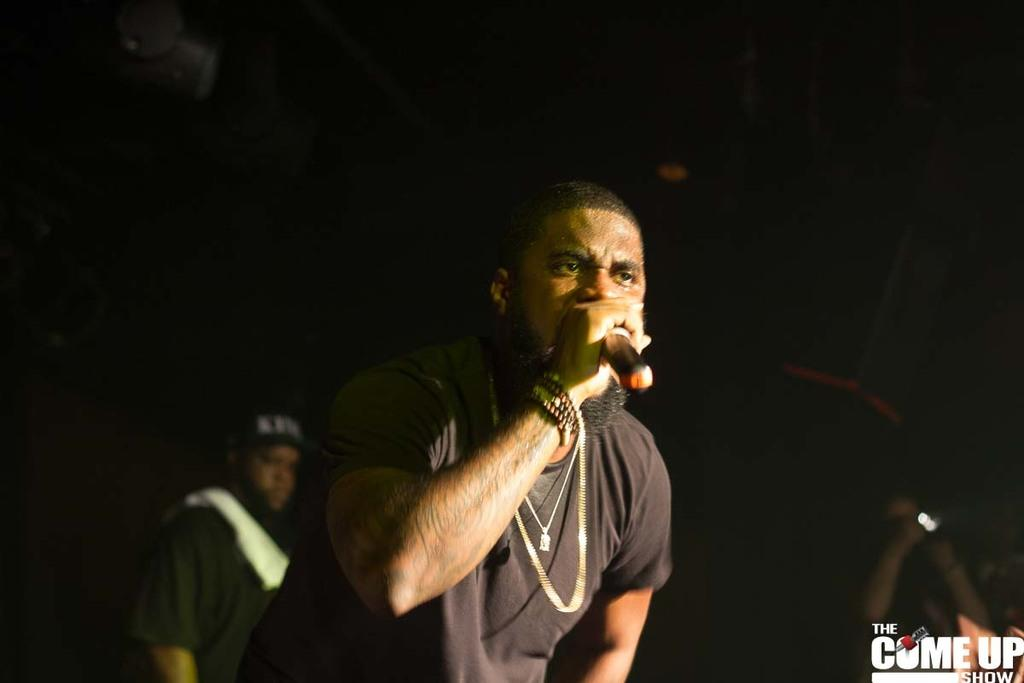What is the person in the foreground of the image holding? The person in the foreground of the image is holding a mic. Can you describe the person in the background of the image? The person in the background of the image is wearing a cap. How many people are visible in the image? There are two people visible in the image. What type of scent can be detected from the plantation in the image? There is no plantation present in the image, so it is not possible to detect any scent. 